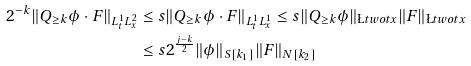Convert formula to latex. <formula><loc_0><loc_0><loc_500><loc_500>2 ^ { - k } \| Q _ { \geq k } \phi \cdot F \| _ { L ^ { 1 } _ { t } L ^ { 2 } _ { x } } & \leq s \| Q _ { \geq k } \phi \cdot F \| _ { L ^ { 1 } _ { t } L ^ { 1 } _ { x } } \leq s \| Q _ { \geq k } \phi \| _ { \L t w o t x } \| F \| _ { \L t w o t x } \\ & \leq s 2 ^ { \frac { j - k } { 2 } } \| \phi \| _ { S [ k _ { 1 } ] } \| F \| _ { N [ k _ { 2 } ] }</formula> 